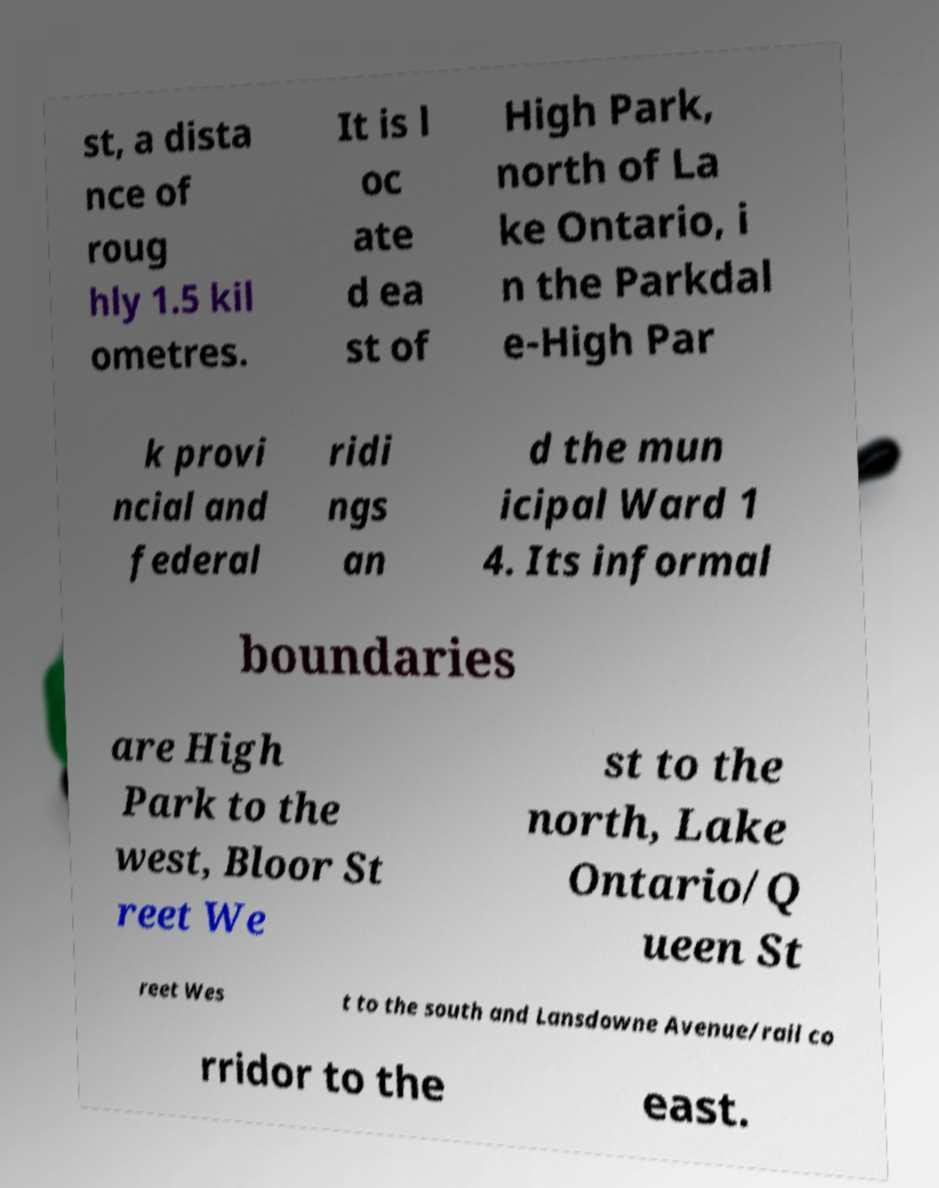Could you assist in decoding the text presented in this image and type it out clearly? st, a dista nce of roug hly 1.5 kil ometres. It is l oc ate d ea st of High Park, north of La ke Ontario, i n the Parkdal e-High Par k provi ncial and federal ridi ngs an d the mun icipal Ward 1 4. Its informal boundaries are High Park to the west, Bloor St reet We st to the north, Lake Ontario/Q ueen St reet Wes t to the south and Lansdowne Avenue/rail co rridor to the east. 